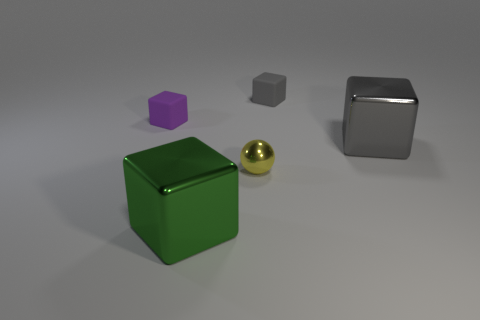How are the objects positioned in relation to each other, and does it appear to be intentional or random? The objects are positioned in a semi-organized manner on a flat surface. The large green and chrome cubes are set toward the outer edges, with the small gray cube and golden sphere centered between them. The purple hexagonal prism is placed above the small gray cube, giving the overall arrangement a sense of balance. While the placement seems deliberate to create a visually pleasing scene, the exact intention behind the arrangement isn't clear without additional context.  Could this arrangement be demonstrating any specific concept in photography or design? This arrangement could be an example of the 'rule of thirds' in photography, where objects are positioned to create interest and energy in the composition. The varying sizes and finishes of the objects also showcase contrast and depth, elements that are often used in design to make compositions more dynamic and engaging. Moreover, the lighting and shadows could be demonstrating techniques to highlight textures and materials in product visualization. 